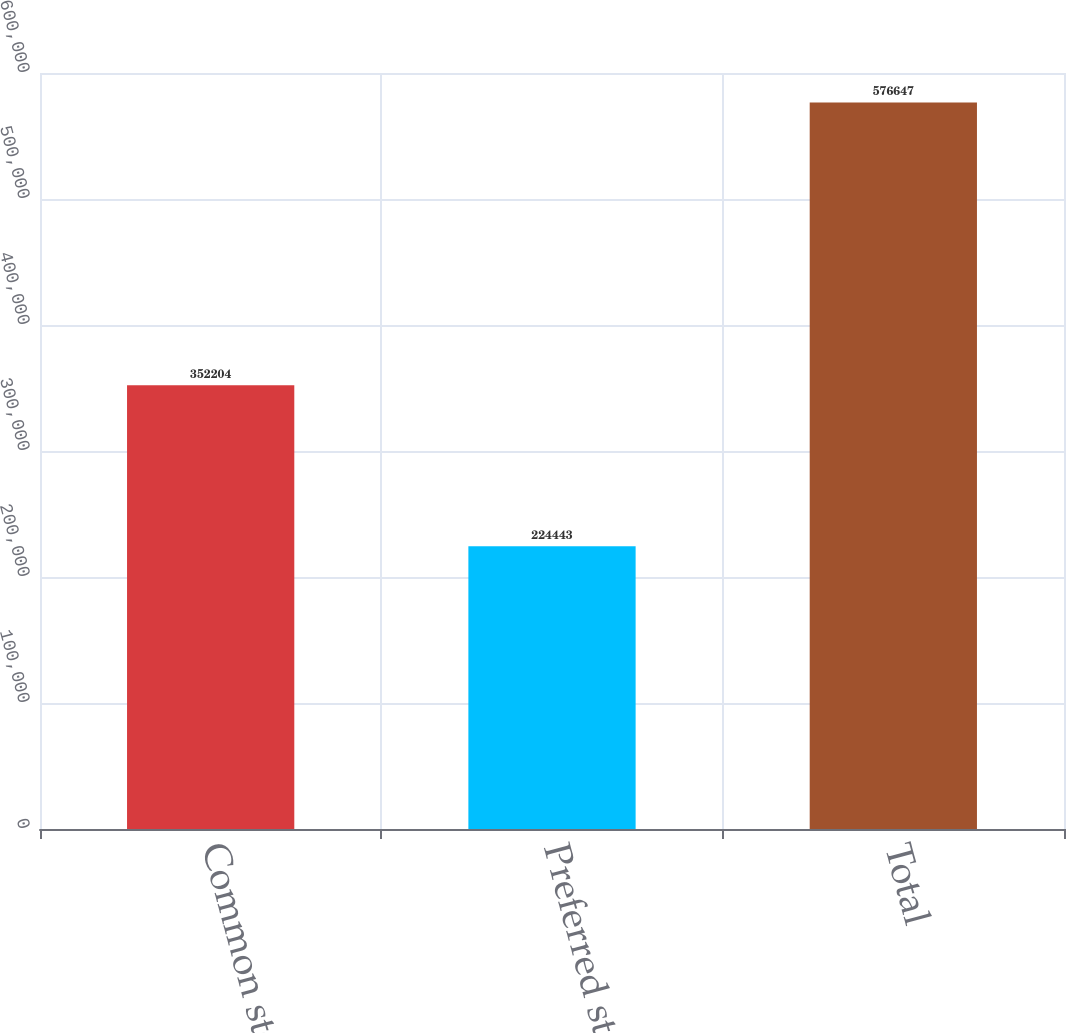Convert chart to OTSL. <chart><loc_0><loc_0><loc_500><loc_500><bar_chart><fcel>Common stocks<fcel>Preferred stocks<fcel>Total<nl><fcel>352204<fcel>224443<fcel>576647<nl></chart> 